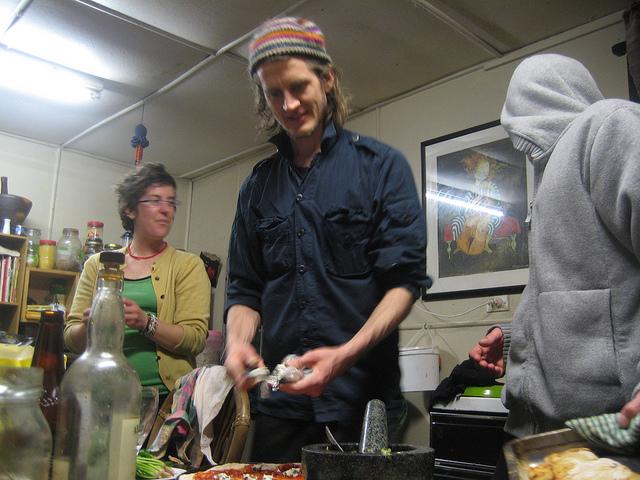What are they cooking?
Concise answer only. Pizza. Are these people having fun?
Quick response, please. Yes. What is the clear covering over the pants?
Write a very short answer. Apron. Do these people look happy?
Give a very brief answer. Yes. What is on the man's head?
Short answer required. Beanie. 